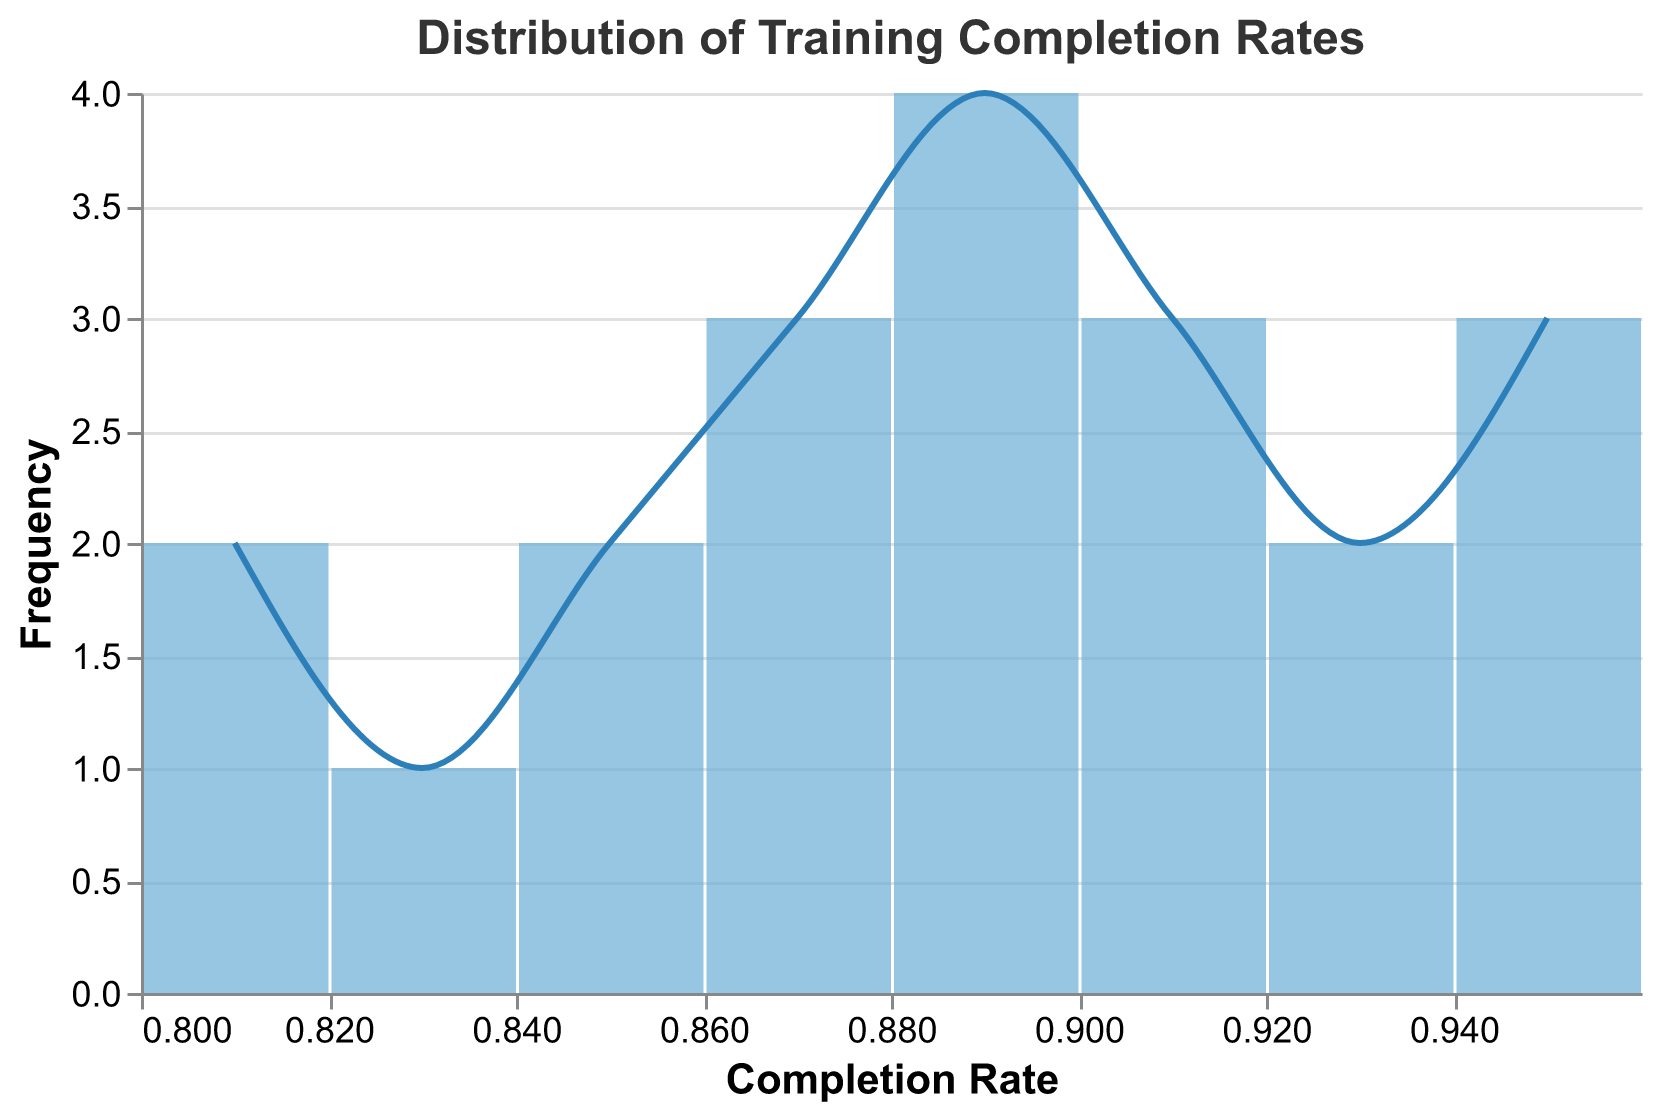What's the range of completion rates found in the data? To find the range, identify the minimum and maximum values of the Completion Rate axis. The minimum is 0.80, and the maximum is 0.96. Subtract the minimum from the maximum: 0.96 - 0.80 = 0.16
Answer: 0.16 How many employees have a completion rate between 0.85 and 0.90? Count the number of bars within this interval on the x-axis. Bars for values 0.85 to 0.90 include multiple ticks, resulting in a specific count.
Answer: 8 Which completion rate interval has the highest frequency? Identify the tallest bar on the plot, which represents the range with the highest occurrence.
Answer: 0.87-0.88 What's the total number of employees represented in the data? Count the total number of frequencies represented by the height of each bar combined. Sum frequencies for all intervals for the total.
Answer: 20 What is the average completion rate of employees? Identify the midpoint of each interval, multiply it by the frequency of that interval, and then divide the sum of these values by the total number of data points (20).
Answer: 0.88 Are there more employees with completion rates below or above 0.90? Compare the sum of frequencies of bars whose x-values are below 0.90 with those above 0.90.
Answer: Below 0.90 Which department seems to have the best performance based on completion rates? Identify the department with the most data points in the highest completion rate intervals (between 0.90 and 0.96).
Answer: Public Safety What does the line plot superimposed on the bar chart represent? The line plot provides a smoothed visual representation of the frequency distribution pattern of completion rates.
Answer: Smoothed frequency distribution Do all departments show a uniform distribution of completion rates? Check for any patterns or clusters of completion rates specific to certain departments within the intervals.
Answer: No Is there any indication of outliers in the completion rates? Check for any bars that are significantly taller or shorter relative to others within the majority range. Outliers would be distant from other data points.
Answer: No 